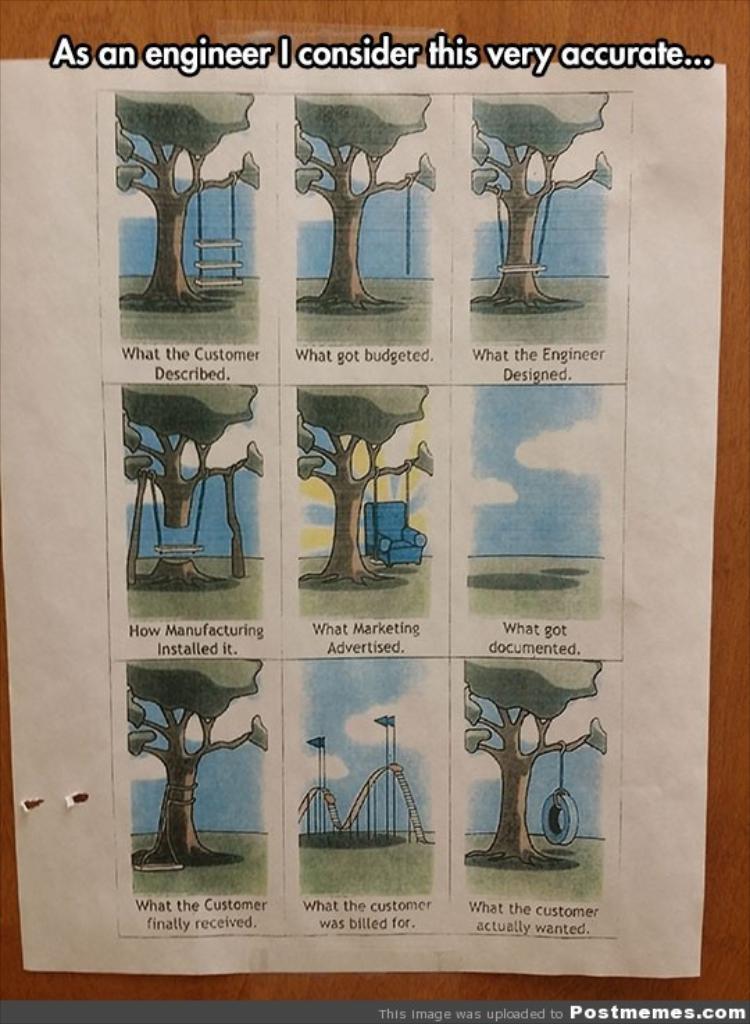Please provide a concise description of this image. In this picture we can see a paper on the wooden surface and on this paper we can see trees, chair, flags, swings, ladder, some objects, some text and at the top and bottom of this picture we can see some text. 